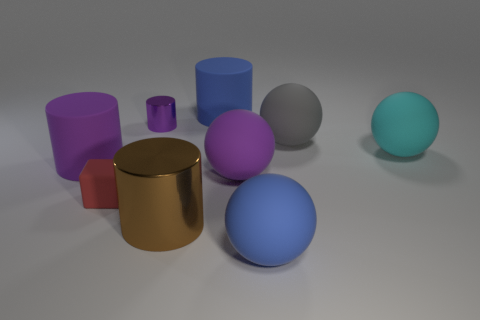What is the size of the gray sphere that is the same material as the big cyan object?
Keep it short and to the point. Large. There is a blue matte object that is in front of the small rubber cube; is its shape the same as the big gray matte object?
Keep it short and to the point. Yes. What size is the other cylinder that is the same color as the tiny cylinder?
Keep it short and to the point. Large. How many green objects are either small metal things or matte blocks?
Your answer should be compact. 0. What number of other things are there of the same shape as the brown metallic thing?
Provide a succinct answer. 3. What shape is the large thing that is in front of the large purple matte sphere and behind the big blue matte ball?
Provide a short and direct response. Cylinder. Are there any matte objects in front of the small red matte object?
Ensure brevity in your answer.  Yes. What size is the other metallic object that is the same shape as the large brown thing?
Keep it short and to the point. Small. Are there any other things that are the same size as the red matte block?
Give a very brief answer. Yes. Is the shape of the red thing the same as the cyan matte thing?
Your answer should be compact. No. 